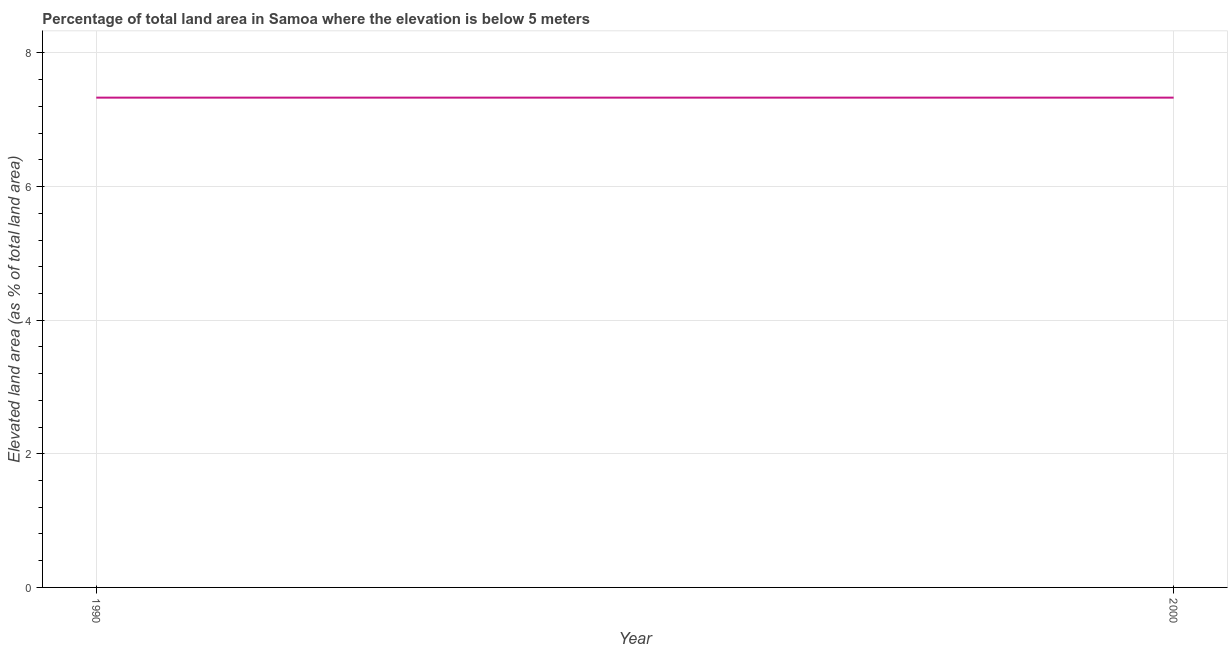What is the total elevated land area in 1990?
Your answer should be compact. 7.33. Across all years, what is the maximum total elevated land area?
Offer a terse response. 7.33. Across all years, what is the minimum total elevated land area?
Provide a succinct answer. 7.33. In which year was the total elevated land area maximum?
Ensure brevity in your answer.  1990. What is the sum of the total elevated land area?
Your response must be concise. 14.66. What is the difference between the total elevated land area in 1990 and 2000?
Provide a succinct answer. 0. What is the average total elevated land area per year?
Provide a short and direct response. 7.33. What is the median total elevated land area?
Keep it short and to the point. 7.33. Do a majority of the years between 1990 and 2000 (inclusive) have total elevated land area greater than 6.4 %?
Keep it short and to the point. Yes. In how many years, is the total elevated land area greater than the average total elevated land area taken over all years?
Provide a short and direct response. 0. How many lines are there?
Ensure brevity in your answer.  1. What is the difference between two consecutive major ticks on the Y-axis?
Ensure brevity in your answer.  2. Are the values on the major ticks of Y-axis written in scientific E-notation?
Your answer should be very brief. No. Does the graph contain any zero values?
Ensure brevity in your answer.  No. Does the graph contain grids?
Your response must be concise. Yes. What is the title of the graph?
Keep it short and to the point. Percentage of total land area in Samoa where the elevation is below 5 meters. What is the label or title of the X-axis?
Give a very brief answer. Year. What is the label or title of the Y-axis?
Provide a succinct answer. Elevated land area (as % of total land area). What is the Elevated land area (as % of total land area) in 1990?
Keep it short and to the point. 7.33. What is the Elevated land area (as % of total land area) in 2000?
Give a very brief answer. 7.33. What is the ratio of the Elevated land area (as % of total land area) in 1990 to that in 2000?
Offer a terse response. 1. 